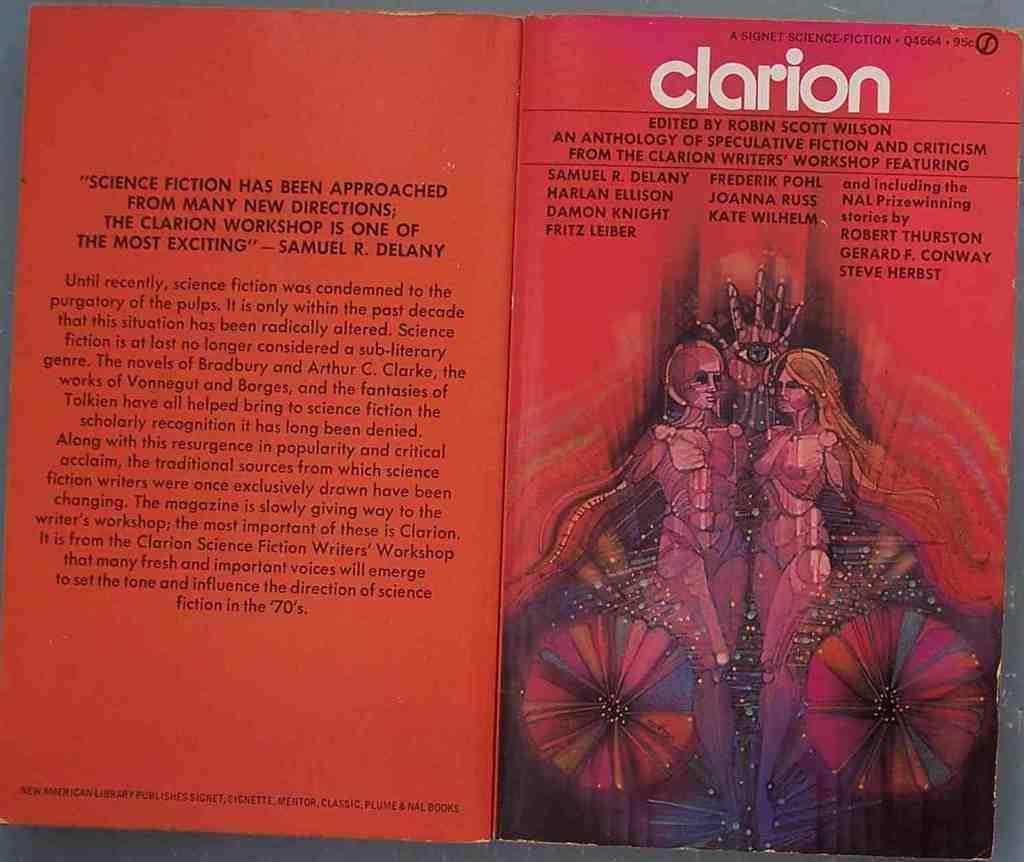Provide a one-sentence caption for the provided image. The front and back of a book called clarion. 